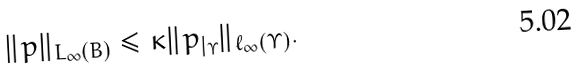Convert formula to latex. <formula><loc_0><loc_0><loc_500><loc_500>\| p \| _ { L _ { \infty } ( B ) } \leq \kappa \| p _ { | _ { \Upsilon } } \| _ { \ell _ { \infty } ( \Upsilon ) } .</formula> 